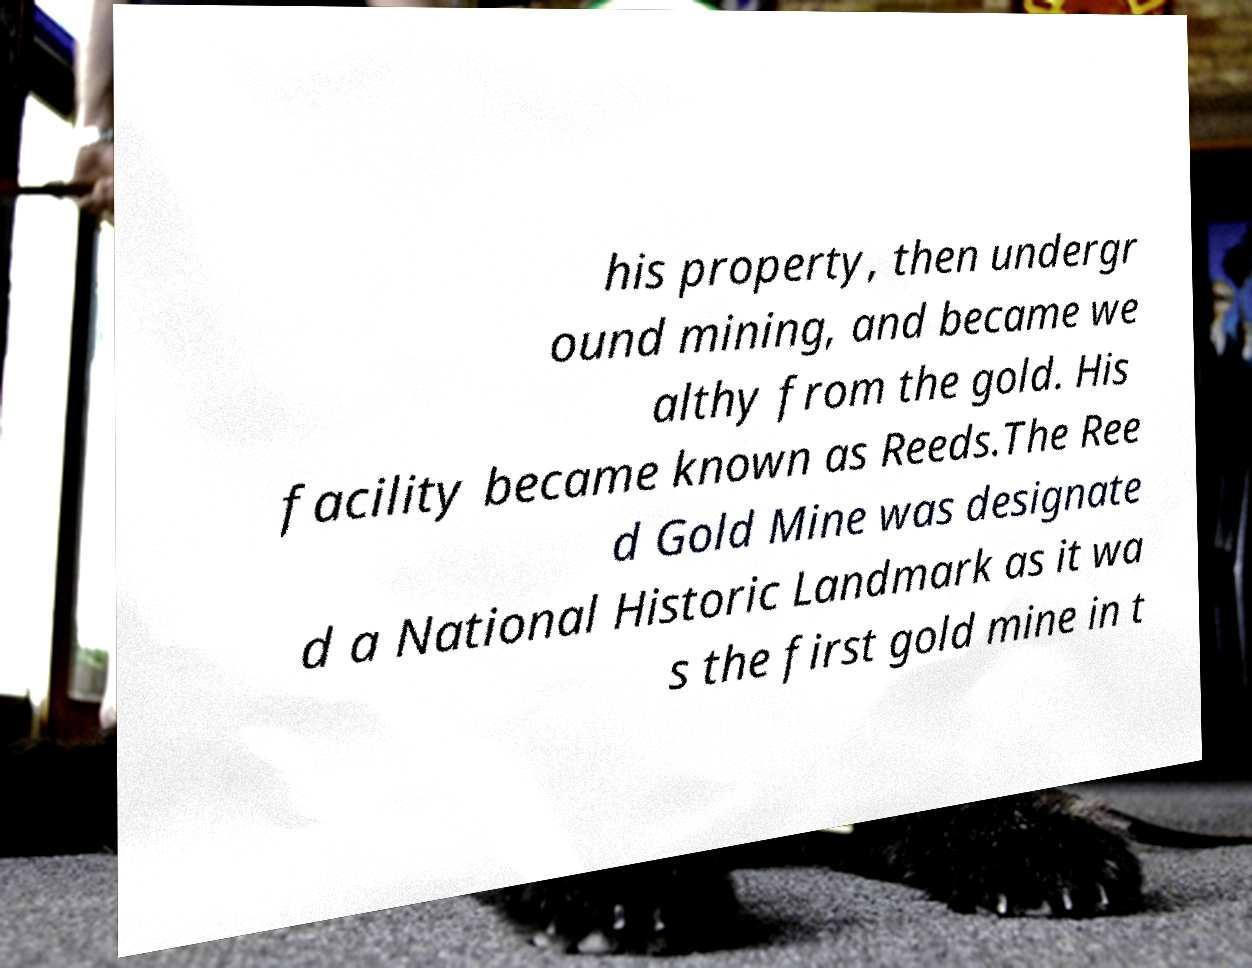Can you read and provide the text displayed in the image?This photo seems to have some interesting text. Can you extract and type it out for me? his property, then undergr ound mining, and became we althy from the gold. His facility became known as Reeds.The Ree d Gold Mine was designate d a National Historic Landmark as it wa s the first gold mine in t 